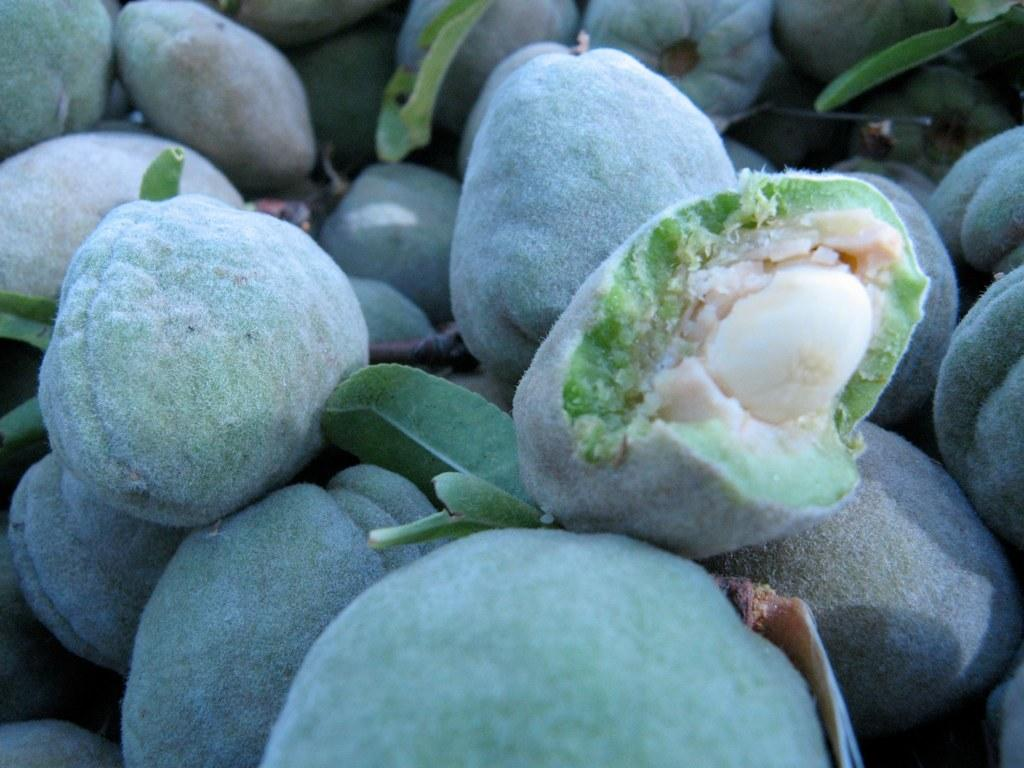What type of food can be seen in the image? There are fruits in the image. What else is present in the image besides the fruits? There are leaves in the image. What color is the hat worn by the fruit in the image? There is no hat present in the image, and the fruits do not wear hats. 